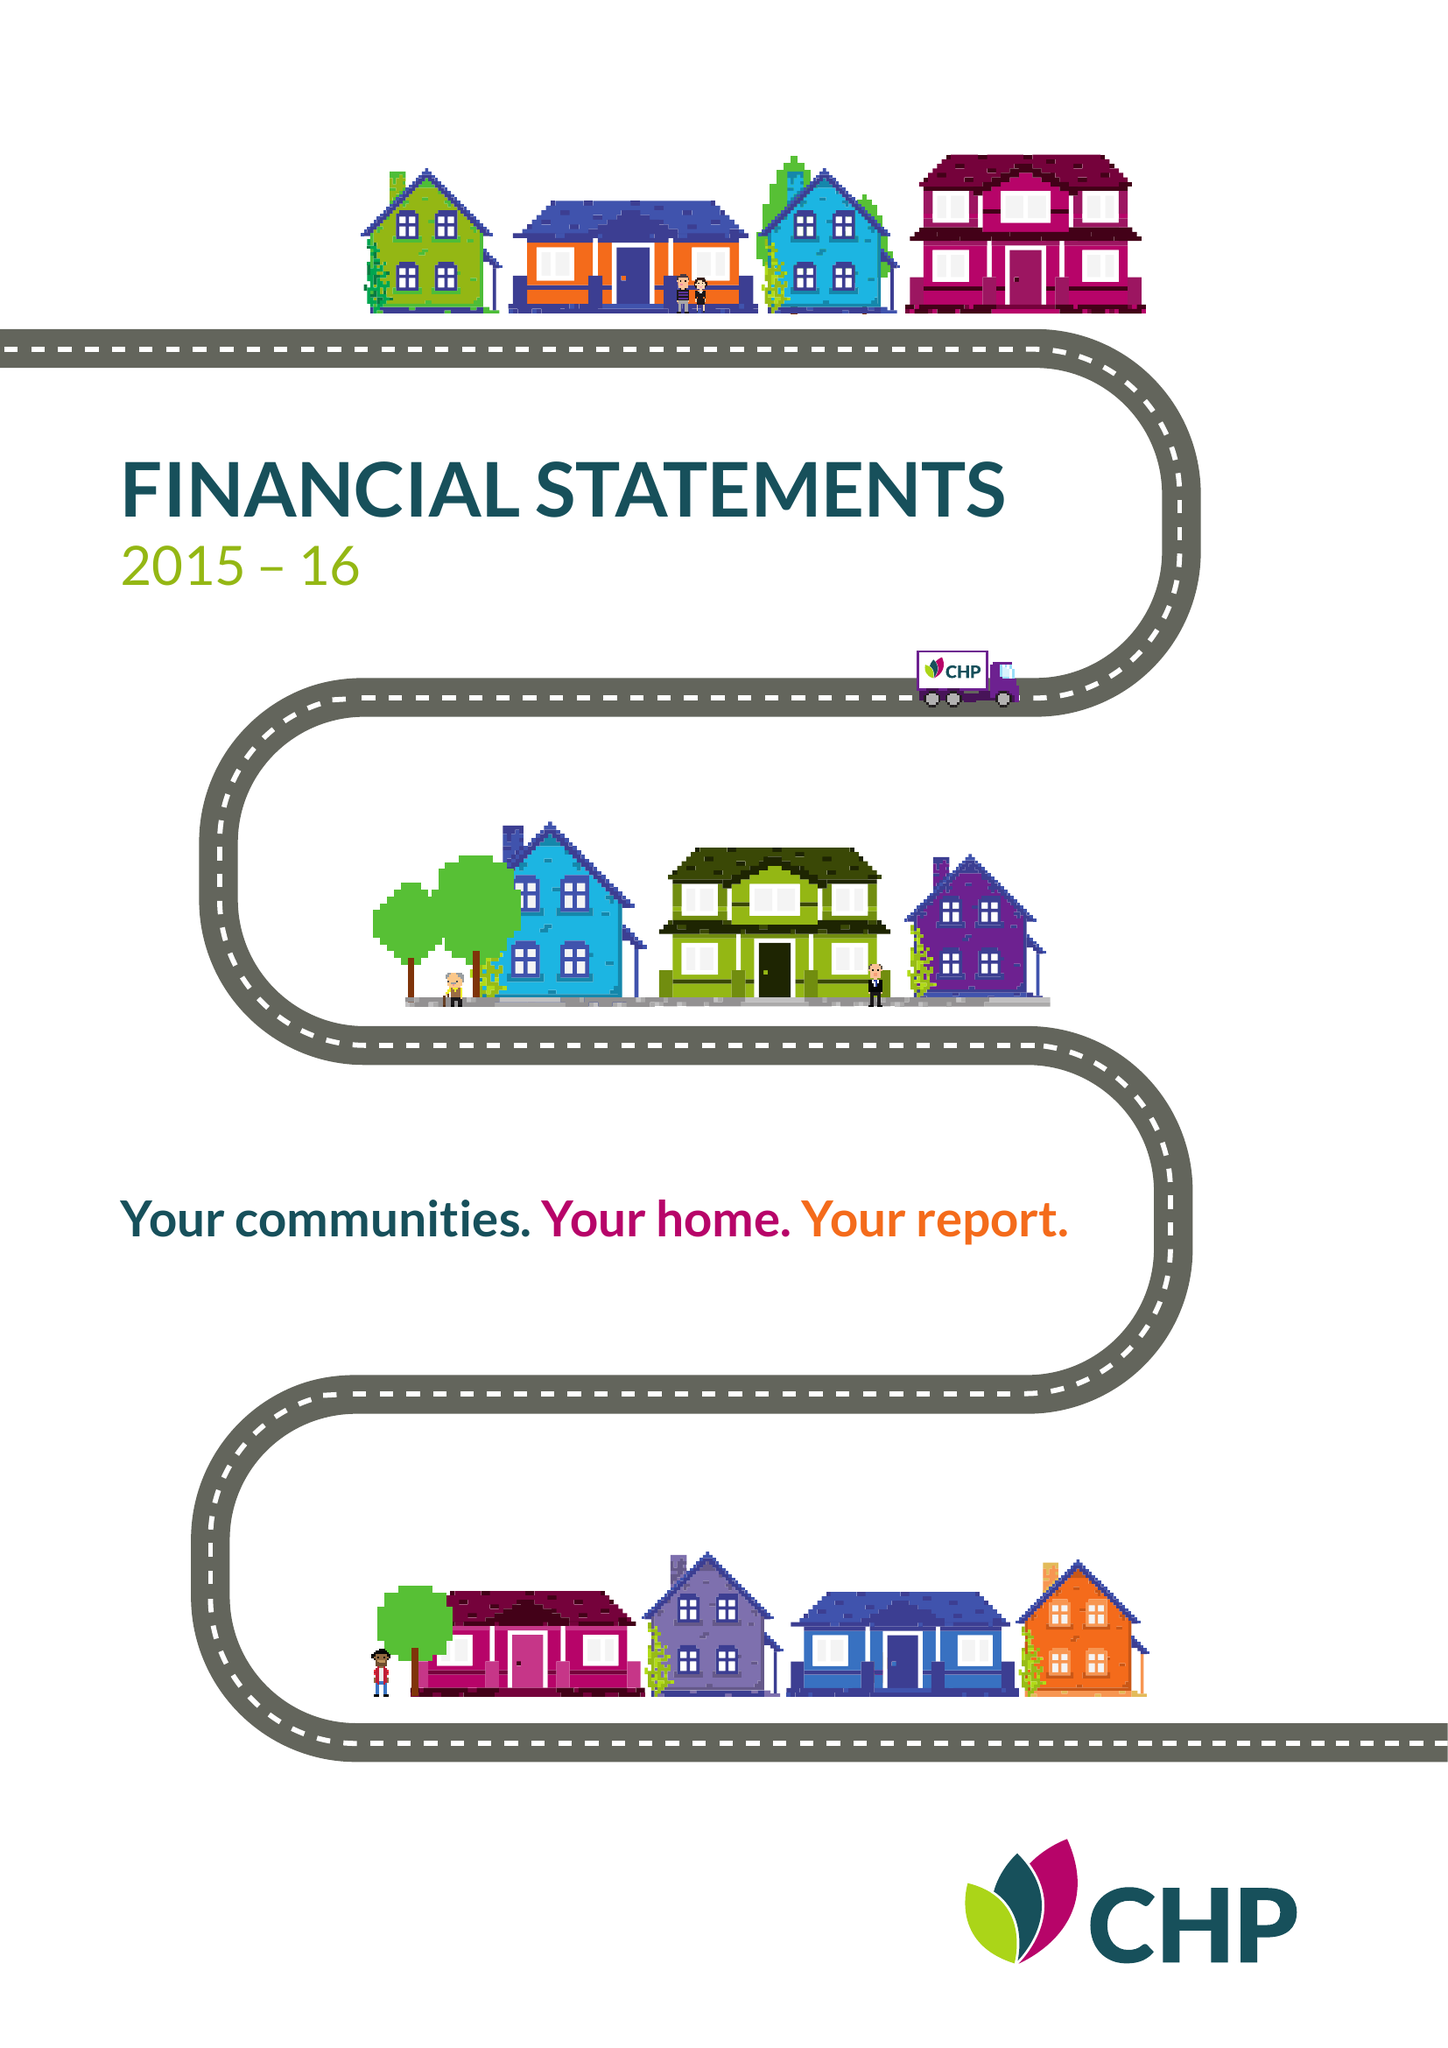What is the value for the charity_name?
Answer the question using a single word or phrase. Chelmer Housing Partnership Ltd. 